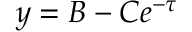Convert formula to latex. <formula><loc_0><loc_0><loc_500><loc_500>y = B - C e ^ { - \tau }</formula> 